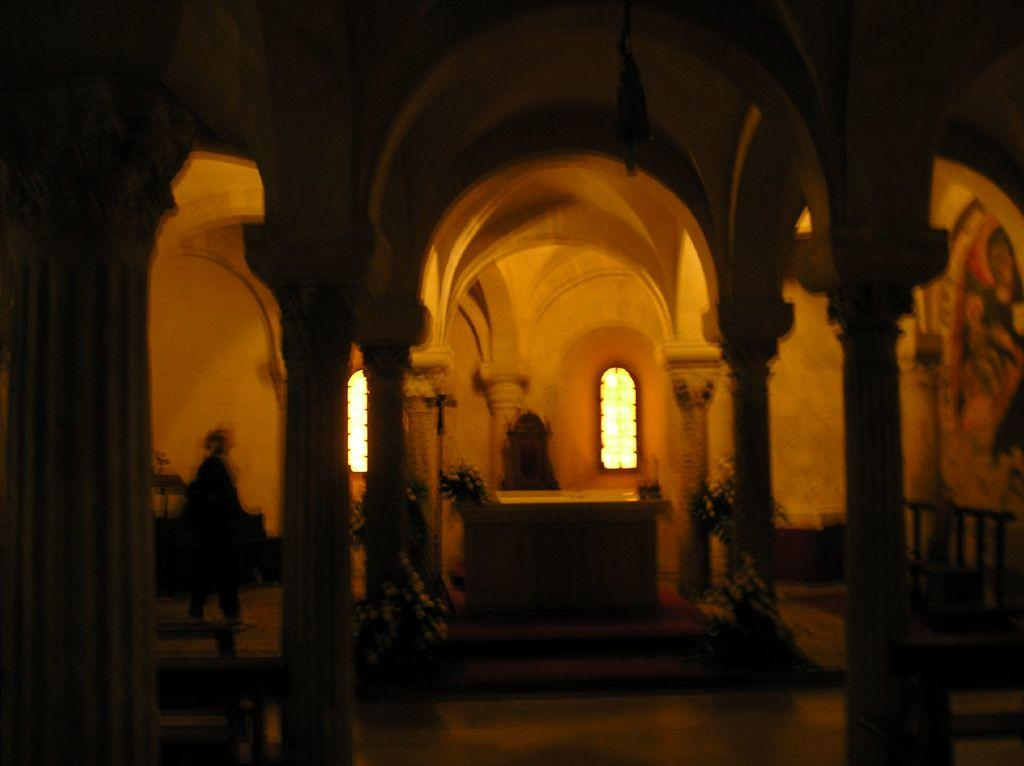What is the overall lighting condition in the image? The image is dark. What architectural features can be seen in the image? There are pillars in the image. What decorative elements are present in the image? There are flower bouquets in the image. Can you describe the person in the image? There is a person standing in the image. What type of furniture is visible in the image? There is a table in the image. What part of a building is visible in the image? There are windows of a building in the image. What is the reason for the hook being present in the image? There is no hook present in the image. 